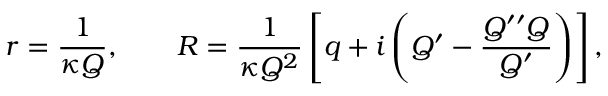Convert formula to latex. <formula><loc_0><loc_0><loc_500><loc_500>r = \frac { 1 } { \kappa Q } , \quad R = \frac { 1 } { \kappa Q ^ { 2 } } \left [ q + i \left ( Q ^ { \prime } - \frac { Q ^ { \prime \prime } Q } { Q ^ { \prime } } \right ) \right ] ,</formula> 